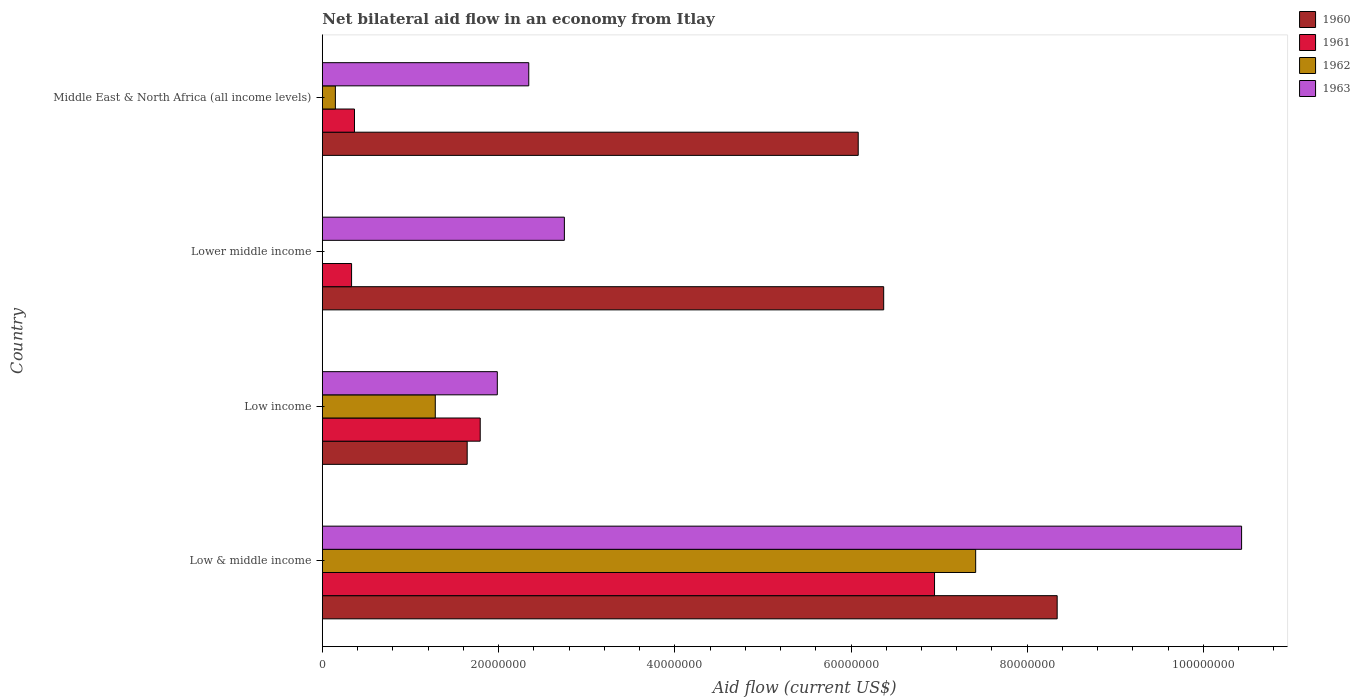How many different coloured bars are there?
Give a very brief answer. 4. How many groups of bars are there?
Offer a terse response. 4. Are the number of bars per tick equal to the number of legend labels?
Offer a very short reply. No. How many bars are there on the 1st tick from the top?
Your answer should be compact. 4. How many bars are there on the 3rd tick from the bottom?
Your response must be concise. 3. What is the label of the 1st group of bars from the top?
Provide a short and direct response. Middle East & North Africa (all income levels). In how many cases, is the number of bars for a given country not equal to the number of legend labels?
Give a very brief answer. 1. What is the net bilateral aid flow in 1963 in Middle East & North Africa (all income levels)?
Make the answer very short. 2.34e+07. Across all countries, what is the maximum net bilateral aid flow in 1961?
Make the answer very short. 6.95e+07. Across all countries, what is the minimum net bilateral aid flow in 1960?
Your answer should be very brief. 1.64e+07. In which country was the net bilateral aid flow in 1962 maximum?
Your answer should be very brief. Low & middle income. What is the total net bilateral aid flow in 1962 in the graph?
Provide a short and direct response. 8.84e+07. What is the difference between the net bilateral aid flow in 1963 in Low income and that in Lower middle income?
Give a very brief answer. -7.61e+06. What is the difference between the net bilateral aid flow in 1962 in Lower middle income and the net bilateral aid flow in 1963 in Low & middle income?
Give a very brief answer. -1.04e+08. What is the average net bilateral aid flow in 1960 per country?
Offer a terse response. 5.61e+07. What is the difference between the net bilateral aid flow in 1960 and net bilateral aid flow in 1963 in Middle East & North Africa (all income levels)?
Offer a very short reply. 3.74e+07. In how many countries, is the net bilateral aid flow in 1963 greater than 76000000 US$?
Your response must be concise. 1. What is the ratio of the net bilateral aid flow in 1963 in Low & middle income to that in Lower middle income?
Provide a succinct answer. 3.8. Is the net bilateral aid flow in 1963 in Low income less than that in Lower middle income?
Give a very brief answer. Yes. What is the difference between the highest and the second highest net bilateral aid flow in 1963?
Offer a very short reply. 7.69e+07. What is the difference between the highest and the lowest net bilateral aid flow in 1960?
Offer a terse response. 6.70e+07. In how many countries, is the net bilateral aid flow in 1963 greater than the average net bilateral aid flow in 1963 taken over all countries?
Provide a short and direct response. 1. Is the sum of the net bilateral aid flow in 1961 in Lower middle income and Middle East & North Africa (all income levels) greater than the maximum net bilateral aid flow in 1963 across all countries?
Ensure brevity in your answer.  No. Is it the case that in every country, the sum of the net bilateral aid flow in 1962 and net bilateral aid flow in 1961 is greater than the net bilateral aid flow in 1960?
Give a very brief answer. No. How many countries are there in the graph?
Your answer should be compact. 4. What is the difference between two consecutive major ticks on the X-axis?
Provide a short and direct response. 2.00e+07. Does the graph contain grids?
Keep it short and to the point. No. Where does the legend appear in the graph?
Provide a short and direct response. Top right. What is the title of the graph?
Ensure brevity in your answer.  Net bilateral aid flow in an economy from Itlay. Does "1989" appear as one of the legend labels in the graph?
Ensure brevity in your answer.  No. What is the label or title of the Y-axis?
Offer a terse response. Country. What is the Aid flow (current US$) of 1960 in Low & middle income?
Keep it short and to the point. 8.34e+07. What is the Aid flow (current US$) of 1961 in Low & middle income?
Your response must be concise. 6.95e+07. What is the Aid flow (current US$) in 1962 in Low & middle income?
Your response must be concise. 7.42e+07. What is the Aid flow (current US$) of 1963 in Low & middle income?
Ensure brevity in your answer.  1.04e+08. What is the Aid flow (current US$) in 1960 in Low income?
Ensure brevity in your answer.  1.64e+07. What is the Aid flow (current US$) in 1961 in Low income?
Give a very brief answer. 1.79e+07. What is the Aid flow (current US$) of 1962 in Low income?
Make the answer very short. 1.28e+07. What is the Aid flow (current US$) in 1963 in Low income?
Offer a very short reply. 1.99e+07. What is the Aid flow (current US$) of 1960 in Lower middle income?
Your answer should be compact. 6.37e+07. What is the Aid flow (current US$) of 1961 in Lower middle income?
Provide a short and direct response. 3.32e+06. What is the Aid flow (current US$) in 1963 in Lower middle income?
Ensure brevity in your answer.  2.75e+07. What is the Aid flow (current US$) of 1960 in Middle East & North Africa (all income levels)?
Provide a succinct answer. 6.08e+07. What is the Aid flow (current US$) in 1961 in Middle East & North Africa (all income levels)?
Ensure brevity in your answer.  3.65e+06. What is the Aid flow (current US$) in 1962 in Middle East & North Africa (all income levels)?
Offer a very short reply. 1.48e+06. What is the Aid flow (current US$) of 1963 in Middle East & North Africa (all income levels)?
Your answer should be compact. 2.34e+07. Across all countries, what is the maximum Aid flow (current US$) in 1960?
Your answer should be very brief. 8.34e+07. Across all countries, what is the maximum Aid flow (current US$) in 1961?
Offer a terse response. 6.95e+07. Across all countries, what is the maximum Aid flow (current US$) of 1962?
Your response must be concise. 7.42e+07. Across all countries, what is the maximum Aid flow (current US$) of 1963?
Provide a short and direct response. 1.04e+08. Across all countries, what is the minimum Aid flow (current US$) of 1960?
Your response must be concise. 1.64e+07. Across all countries, what is the minimum Aid flow (current US$) of 1961?
Offer a terse response. 3.32e+06. Across all countries, what is the minimum Aid flow (current US$) in 1962?
Your response must be concise. 0. Across all countries, what is the minimum Aid flow (current US$) of 1963?
Give a very brief answer. 1.99e+07. What is the total Aid flow (current US$) in 1960 in the graph?
Provide a short and direct response. 2.24e+08. What is the total Aid flow (current US$) in 1961 in the graph?
Offer a very short reply. 9.44e+07. What is the total Aid flow (current US$) of 1962 in the graph?
Make the answer very short. 8.84e+07. What is the total Aid flow (current US$) in 1963 in the graph?
Ensure brevity in your answer.  1.75e+08. What is the difference between the Aid flow (current US$) of 1960 in Low & middle income and that in Low income?
Make the answer very short. 6.70e+07. What is the difference between the Aid flow (current US$) in 1961 in Low & middle income and that in Low income?
Provide a succinct answer. 5.16e+07. What is the difference between the Aid flow (current US$) in 1962 in Low & middle income and that in Low income?
Ensure brevity in your answer.  6.13e+07. What is the difference between the Aid flow (current US$) in 1963 in Low & middle income and that in Low income?
Give a very brief answer. 8.45e+07. What is the difference between the Aid flow (current US$) of 1960 in Low & middle income and that in Lower middle income?
Make the answer very short. 1.97e+07. What is the difference between the Aid flow (current US$) in 1961 in Low & middle income and that in Lower middle income?
Make the answer very short. 6.62e+07. What is the difference between the Aid flow (current US$) of 1963 in Low & middle income and that in Lower middle income?
Provide a succinct answer. 7.69e+07. What is the difference between the Aid flow (current US$) of 1960 in Low & middle income and that in Middle East & North Africa (all income levels)?
Make the answer very short. 2.26e+07. What is the difference between the Aid flow (current US$) of 1961 in Low & middle income and that in Middle East & North Africa (all income levels)?
Your answer should be compact. 6.58e+07. What is the difference between the Aid flow (current US$) in 1962 in Low & middle income and that in Middle East & North Africa (all income levels)?
Offer a terse response. 7.27e+07. What is the difference between the Aid flow (current US$) of 1963 in Low & middle income and that in Middle East & North Africa (all income levels)?
Make the answer very short. 8.09e+07. What is the difference between the Aid flow (current US$) of 1960 in Low income and that in Lower middle income?
Provide a succinct answer. -4.73e+07. What is the difference between the Aid flow (current US$) of 1961 in Low income and that in Lower middle income?
Your response must be concise. 1.46e+07. What is the difference between the Aid flow (current US$) in 1963 in Low income and that in Lower middle income?
Give a very brief answer. -7.61e+06. What is the difference between the Aid flow (current US$) of 1960 in Low income and that in Middle East & North Africa (all income levels)?
Give a very brief answer. -4.44e+07. What is the difference between the Aid flow (current US$) of 1961 in Low income and that in Middle East & North Africa (all income levels)?
Provide a short and direct response. 1.43e+07. What is the difference between the Aid flow (current US$) of 1962 in Low income and that in Middle East & North Africa (all income levels)?
Provide a succinct answer. 1.13e+07. What is the difference between the Aid flow (current US$) in 1963 in Low income and that in Middle East & North Africa (all income levels)?
Provide a short and direct response. -3.57e+06. What is the difference between the Aid flow (current US$) in 1960 in Lower middle income and that in Middle East & North Africa (all income levels)?
Keep it short and to the point. 2.89e+06. What is the difference between the Aid flow (current US$) of 1961 in Lower middle income and that in Middle East & North Africa (all income levels)?
Offer a very short reply. -3.30e+05. What is the difference between the Aid flow (current US$) in 1963 in Lower middle income and that in Middle East & North Africa (all income levels)?
Provide a succinct answer. 4.04e+06. What is the difference between the Aid flow (current US$) of 1960 in Low & middle income and the Aid flow (current US$) of 1961 in Low income?
Your answer should be compact. 6.55e+07. What is the difference between the Aid flow (current US$) in 1960 in Low & middle income and the Aid flow (current US$) in 1962 in Low income?
Your answer should be compact. 7.06e+07. What is the difference between the Aid flow (current US$) in 1960 in Low & middle income and the Aid flow (current US$) in 1963 in Low income?
Make the answer very short. 6.35e+07. What is the difference between the Aid flow (current US$) of 1961 in Low & middle income and the Aid flow (current US$) of 1962 in Low income?
Your answer should be compact. 5.67e+07. What is the difference between the Aid flow (current US$) in 1961 in Low & middle income and the Aid flow (current US$) in 1963 in Low income?
Offer a very short reply. 4.96e+07. What is the difference between the Aid flow (current US$) in 1962 in Low & middle income and the Aid flow (current US$) in 1963 in Low income?
Keep it short and to the point. 5.43e+07. What is the difference between the Aid flow (current US$) in 1960 in Low & middle income and the Aid flow (current US$) in 1961 in Lower middle income?
Provide a succinct answer. 8.01e+07. What is the difference between the Aid flow (current US$) in 1960 in Low & middle income and the Aid flow (current US$) in 1963 in Lower middle income?
Offer a terse response. 5.59e+07. What is the difference between the Aid flow (current US$) in 1961 in Low & middle income and the Aid flow (current US$) in 1963 in Lower middle income?
Give a very brief answer. 4.20e+07. What is the difference between the Aid flow (current US$) in 1962 in Low & middle income and the Aid flow (current US$) in 1963 in Lower middle income?
Give a very brief answer. 4.67e+07. What is the difference between the Aid flow (current US$) of 1960 in Low & middle income and the Aid flow (current US$) of 1961 in Middle East & North Africa (all income levels)?
Ensure brevity in your answer.  7.98e+07. What is the difference between the Aid flow (current US$) in 1960 in Low & middle income and the Aid flow (current US$) in 1962 in Middle East & North Africa (all income levels)?
Provide a short and direct response. 8.19e+07. What is the difference between the Aid flow (current US$) of 1960 in Low & middle income and the Aid flow (current US$) of 1963 in Middle East & North Africa (all income levels)?
Provide a short and direct response. 6.00e+07. What is the difference between the Aid flow (current US$) in 1961 in Low & middle income and the Aid flow (current US$) in 1962 in Middle East & North Africa (all income levels)?
Offer a very short reply. 6.80e+07. What is the difference between the Aid flow (current US$) in 1961 in Low & middle income and the Aid flow (current US$) in 1963 in Middle East & North Africa (all income levels)?
Your answer should be compact. 4.60e+07. What is the difference between the Aid flow (current US$) of 1962 in Low & middle income and the Aid flow (current US$) of 1963 in Middle East & North Africa (all income levels)?
Ensure brevity in your answer.  5.07e+07. What is the difference between the Aid flow (current US$) in 1960 in Low income and the Aid flow (current US$) in 1961 in Lower middle income?
Give a very brief answer. 1.31e+07. What is the difference between the Aid flow (current US$) in 1960 in Low income and the Aid flow (current US$) in 1963 in Lower middle income?
Provide a short and direct response. -1.10e+07. What is the difference between the Aid flow (current US$) in 1961 in Low income and the Aid flow (current US$) in 1963 in Lower middle income?
Make the answer very short. -9.55e+06. What is the difference between the Aid flow (current US$) of 1962 in Low income and the Aid flow (current US$) of 1963 in Lower middle income?
Provide a short and direct response. -1.46e+07. What is the difference between the Aid flow (current US$) in 1960 in Low income and the Aid flow (current US$) in 1961 in Middle East & North Africa (all income levels)?
Keep it short and to the point. 1.28e+07. What is the difference between the Aid flow (current US$) in 1960 in Low income and the Aid flow (current US$) in 1962 in Middle East & North Africa (all income levels)?
Make the answer very short. 1.50e+07. What is the difference between the Aid flow (current US$) in 1960 in Low income and the Aid flow (current US$) in 1963 in Middle East & North Africa (all income levels)?
Your answer should be very brief. -6.99e+06. What is the difference between the Aid flow (current US$) in 1961 in Low income and the Aid flow (current US$) in 1962 in Middle East & North Africa (all income levels)?
Your answer should be compact. 1.64e+07. What is the difference between the Aid flow (current US$) in 1961 in Low income and the Aid flow (current US$) in 1963 in Middle East & North Africa (all income levels)?
Ensure brevity in your answer.  -5.51e+06. What is the difference between the Aid flow (current US$) in 1962 in Low income and the Aid flow (current US$) in 1963 in Middle East & North Africa (all income levels)?
Ensure brevity in your answer.  -1.06e+07. What is the difference between the Aid flow (current US$) of 1960 in Lower middle income and the Aid flow (current US$) of 1961 in Middle East & North Africa (all income levels)?
Give a very brief answer. 6.01e+07. What is the difference between the Aid flow (current US$) in 1960 in Lower middle income and the Aid flow (current US$) in 1962 in Middle East & North Africa (all income levels)?
Your answer should be very brief. 6.22e+07. What is the difference between the Aid flow (current US$) of 1960 in Lower middle income and the Aid flow (current US$) of 1963 in Middle East & North Africa (all income levels)?
Provide a short and direct response. 4.03e+07. What is the difference between the Aid flow (current US$) of 1961 in Lower middle income and the Aid flow (current US$) of 1962 in Middle East & North Africa (all income levels)?
Your response must be concise. 1.84e+06. What is the difference between the Aid flow (current US$) in 1961 in Lower middle income and the Aid flow (current US$) in 1963 in Middle East & North Africa (all income levels)?
Your answer should be very brief. -2.01e+07. What is the average Aid flow (current US$) of 1960 per country?
Give a very brief answer. 5.61e+07. What is the average Aid flow (current US$) in 1961 per country?
Provide a short and direct response. 2.36e+07. What is the average Aid flow (current US$) in 1962 per country?
Provide a short and direct response. 2.21e+07. What is the average Aid flow (current US$) in 1963 per country?
Give a very brief answer. 4.38e+07. What is the difference between the Aid flow (current US$) in 1960 and Aid flow (current US$) in 1961 in Low & middle income?
Provide a succinct answer. 1.39e+07. What is the difference between the Aid flow (current US$) in 1960 and Aid flow (current US$) in 1962 in Low & middle income?
Make the answer very short. 9.25e+06. What is the difference between the Aid flow (current US$) in 1960 and Aid flow (current US$) in 1963 in Low & middle income?
Offer a terse response. -2.09e+07. What is the difference between the Aid flow (current US$) of 1961 and Aid flow (current US$) of 1962 in Low & middle income?
Your response must be concise. -4.67e+06. What is the difference between the Aid flow (current US$) in 1961 and Aid flow (current US$) in 1963 in Low & middle income?
Keep it short and to the point. -3.48e+07. What is the difference between the Aid flow (current US$) of 1962 and Aid flow (current US$) of 1963 in Low & middle income?
Make the answer very short. -3.02e+07. What is the difference between the Aid flow (current US$) of 1960 and Aid flow (current US$) of 1961 in Low income?
Your answer should be very brief. -1.48e+06. What is the difference between the Aid flow (current US$) of 1960 and Aid flow (current US$) of 1962 in Low income?
Ensure brevity in your answer.  3.62e+06. What is the difference between the Aid flow (current US$) of 1960 and Aid flow (current US$) of 1963 in Low income?
Make the answer very short. -3.42e+06. What is the difference between the Aid flow (current US$) of 1961 and Aid flow (current US$) of 1962 in Low income?
Offer a terse response. 5.10e+06. What is the difference between the Aid flow (current US$) of 1961 and Aid flow (current US$) of 1963 in Low income?
Give a very brief answer. -1.94e+06. What is the difference between the Aid flow (current US$) of 1962 and Aid flow (current US$) of 1963 in Low income?
Provide a succinct answer. -7.04e+06. What is the difference between the Aid flow (current US$) of 1960 and Aid flow (current US$) of 1961 in Lower middle income?
Your answer should be compact. 6.04e+07. What is the difference between the Aid flow (current US$) in 1960 and Aid flow (current US$) in 1963 in Lower middle income?
Your answer should be compact. 3.62e+07. What is the difference between the Aid flow (current US$) of 1961 and Aid flow (current US$) of 1963 in Lower middle income?
Keep it short and to the point. -2.42e+07. What is the difference between the Aid flow (current US$) in 1960 and Aid flow (current US$) in 1961 in Middle East & North Africa (all income levels)?
Give a very brief answer. 5.72e+07. What is the difference between the Aid flow (current US$) in 1960 and Aid flow (current US$) in 1962 in Middle East & North Africa (all income levels)?
Your response must be concise. 5.93e+07. What is the difference between the Aid flow (current US$) in 1960 and Aid flow (current US$) in 1963 in Middle East & North Africa (all income levels)?
Offer a terse response. 3.74e+07. What is the difference between the Aid flow (current US$) of 1961 and Aid flow (current US$) of 1962 in Middle East & North Africa (all income levels)?
Your answer should be very brief. 2.17e+06. What is the difference between the Aid flow (current US$) in 1961 and Aid flow (current US$) in 1963 in Middle East & North Africa (all income levels)?
Offer a very short reply. -1.98e+07. What is the difference between the Aid flow (current US$) in 1962 and Aid flow (current US$) in 1963 in Middle East & North Africa (all income levels)?
Your answer should be compact. -2.20e+07. What is the ratio of the Aid flow (current US$) in 1960 in Low & middle income to that in Low income?
Your response must be concise. 5.07. What is the ratio of the Aid flow (current US$) in 1961 in Low & middle income to that in Low income?
Offer a terse response. 3.88. What is the ratio of the Aid flow (current US$) in 1962 in Low & middle income to that in Low income?
Your answer should be compact. 5.78. What is the ratio of the Aid flow (current US$) of 1963 in Low & middle income to that in Low income?
Provide a short and direct response. 5.25. What is the ratio of the Aid flow (current US$) of 1960 in Low & middle income to that in Lower middle income?
Provide a succinct answer. 1.31. What is the ratio of the Aid flow (current US$) of 1961 in Low & middle income to that in Lower middle income?
Provide a short and direct response. 20.93. What is the ratio of the Aid flow (current US$) in 1963 in Low & middle income to that in Lower middle income?
Your answer should be compact. 3.8. What is the ratio of the Aid flow (current US$) in 1960 in Low & middle income to that in Middle East & North Africa (all income levels)?
Provide a short and direct response. 1.37. What is the ratio of the Aid flow (current US$) in 1961 in Low & middle income to that in Middle East & North Africa (all income levels)?
Ensure brevity in your answer.  19.04. What is the ratio of the Aid flow (current US$) of 1962 in Low & middle income to that in Middle East & North Africa (all income levels)?
Provide a succinct answer. 50.1. What is the ratio of the Aid flow (current US$) of 1963 in Low & middle income to that in Middle East & North Africa (all income levels)?
Give a very brief answer. 4.45. What is the ratio of the Aid flow (current US$) in 1960 in Low income to that in Lower middle income?
Your response must be concise. 0.26. What is the ratio of the Aid flow (current US$) of 1961 in Low income to that in Lower middle income?
Make the answer very short. 5.4. What is the ratio of the Aid flow (current US$) in 1963 in Low income to that in Lower middle income?
Offer a terse response. 0.72. What is the ratio of the Aid flow (current US$) of 1960 in Low income to that in Middle East & North Africa (all income levels)?
Make the answer very short. 0.27. What is the ratio of the Aid flow (current US$) in 1961 in Low income to that in Middle East & North Africa (all income levels)?
Your answer should be compact. 4.91. What is the ratio of the Aid flow (current US$) in 1962 in Low income to that in Middle East & North Africa (all income levels)?
Ensure brevity in your answer.  8.66. What is the ratio of the Aid flow (current US$) of 1963 in Low income to that in Middle East & North Africa (all income levels)?
Provide a short and direct response. 0.85. What is the ratio of the Aid flow (current US$) of 1960 in Lower middle income to that in Middle East & North Africa (all income levels)?
Provide a succinct answer. 1.05. What is the ratio of the Aid flow (current US$) of 1961 in Lower middle income to that in Middle East & North Africa (all income levels)?
Your answer should be very brief. 0.91. What is the ratio of the Aid flow (current US$) of 1963 in Lower middle income to that in Middle East & North Africa (all income levels)?
Keep it short and to the point. 1.17. What is the difference between the highest and the second highest Aid flow (current US$) of 1960?
Keep it short and to the point. 1.97e+07. What is the difference between the highest and the second highest Aid flow (current US$) in 1961?
Provide a short and direct response. 5.16e+07. What is the difference between the highest and the second highest Aid flow (current US$) of 1962?
Provide a short and direct response. 6.13e+07. What is the difference between the highest and the second highest Aid flow (current US$) in 1963?
Provide a succinct answer. 7.69e+07. What is the difference between the highest and the lowest Aid flow (current US$) of 1960?
Your answer should be compact. 6.70e+07. What is the difference between the highest and the lowest Aid flow (current US$) of 1961?
Offer a terse response. 6.62e+07. What is the difference between the highest and the lowest Aid flow (current US$) of 1962?
Offer a terse response. 7.42e+07. What is the difference between the highest and the lowest Aid flow (current US$) of 1963?
Give a very brief answer. 8.45e+07. 